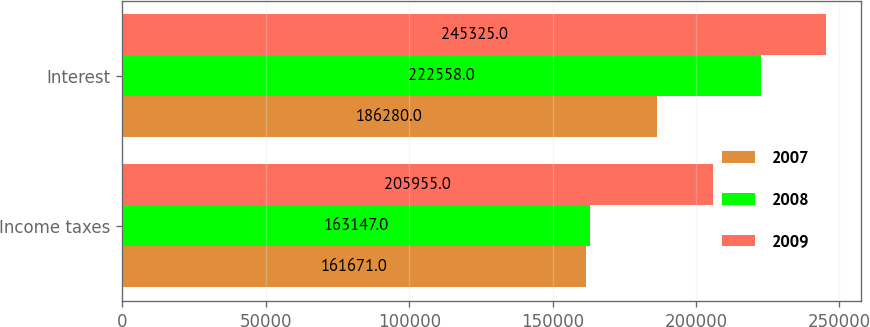Convert chart to OTSL. <chart><loc_0><loc_0><loc_500><loc_500><stacked_bar_chart><ecel><fcel>Income taxes<fcel>Interest<nl><fcel>2007<fcel>161671<fcel>186280<nl><fcel>2008<fcel>163147<fcel>222558<nl><fcel>2009<fcel>205955<fcel>245325<nl></chart> 